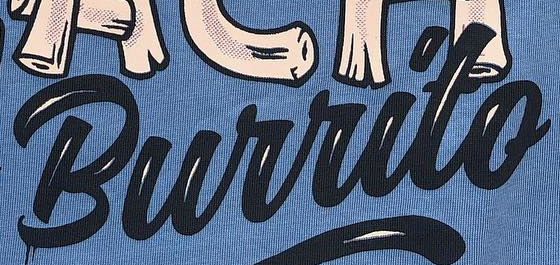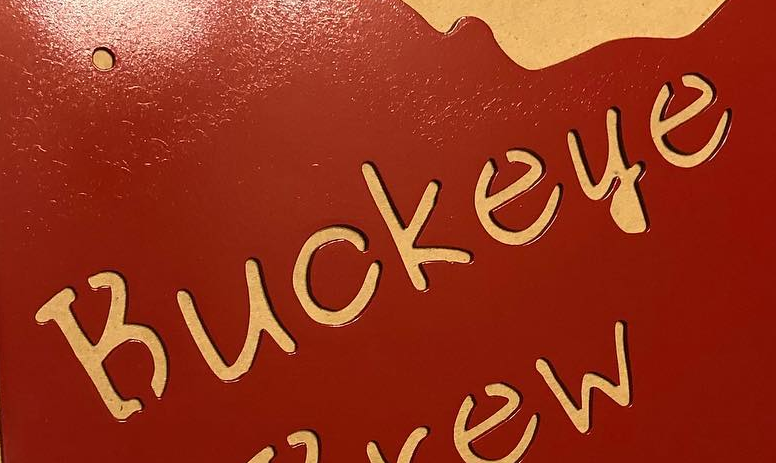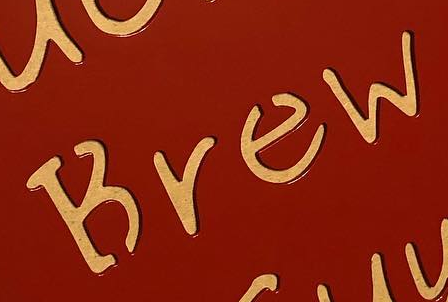What text is displayed in these images sequentially, separated by a semicolon? Burrito; Buckeye; Brew 